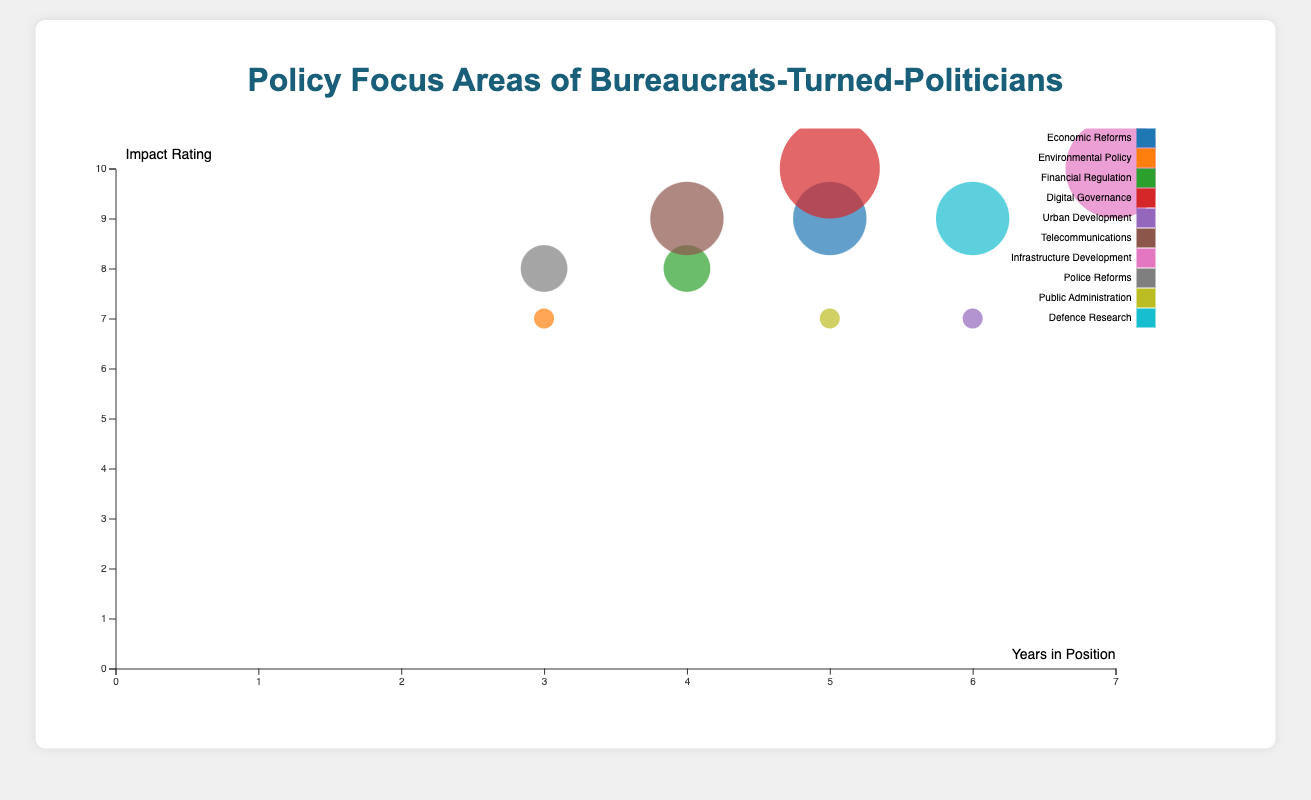How many policy focus areas have an impact rating of 10? The bubble chart displays bubbles of varying sizes, with larger bubbles representing higher impact ratings. By identifying the largest bubbles and counting them, we find two areas: "Digital Governance" and "Infrastructure Development".
Answer: 2 Which bureaucrat had the longest tenure in their previous position? The x-axis represents years in position. By identifying the bubble furthest to the right, attributed to "E. Sreedharan" in "Infrastructure Development", who had 7 years in position.
Answer: E. Sreedharan What is the average impact rating of bureaucrats working on policies related to Urban Development and Public Administration? Identify the bubbles for "Urban Development" and "Public Administration" with impact ratings of 7 each. The average is the sum divided by the count: (7 + 7) / 2 = 7.
Answer: 7 Compare the impact ratings of Arvind Subramanian and Shaktikanta Das. Who has the higher rating? Locate the bubbles for "Economic Reforms" (Arvind Subramanian) and "Financial Regulation" (Shaktikanta Das). Arvind Subramanian has a rating of 9, whereas Shaktikanta Das has a rating of 8.
Answer: Arvind Subramanian What is the total number of policy focus areas represented in the chart? Each unique color represents different policy focus areas. Counting the distinct colors results in 10 different policy focus areas.
Answer: 10 Which bureaucrat has influenced Digital Governance, and what is their impact rating? For the policy focus on Digital Governance, locate the corresponding bubble. It is associated with "Nandan Nilekani" who has an impact rating of 10.
Answer: Nandan Nilekani, 10 Which policy focus area has the highest average impact rating? Calculate the average impact rating for each policy area. Digital Governance and Infrastructure Development both have a single individual with a 10 rating, making them highest by default.
Answer: Digital Governance and Infrastructure Development Identify the bureaucrat with the policy focus on Defence Research and their tenure in their previous position. Locate the bubble for Defence Research which corresponds to "V. K. Saraswat". His tenure is shown by the x position of the bubble as 6 years.
Answer: V. K. Saraswat, 6 years How many bureaucrats had an impact rating greater than 8? Filter the bubbles to those with impact ratings greater than 8, which includes Arvind Subramanian (9), Nandan Nilekani (10), Aruna Sundararajan (9), and E. Sreedharan (10).
Answer: 4 